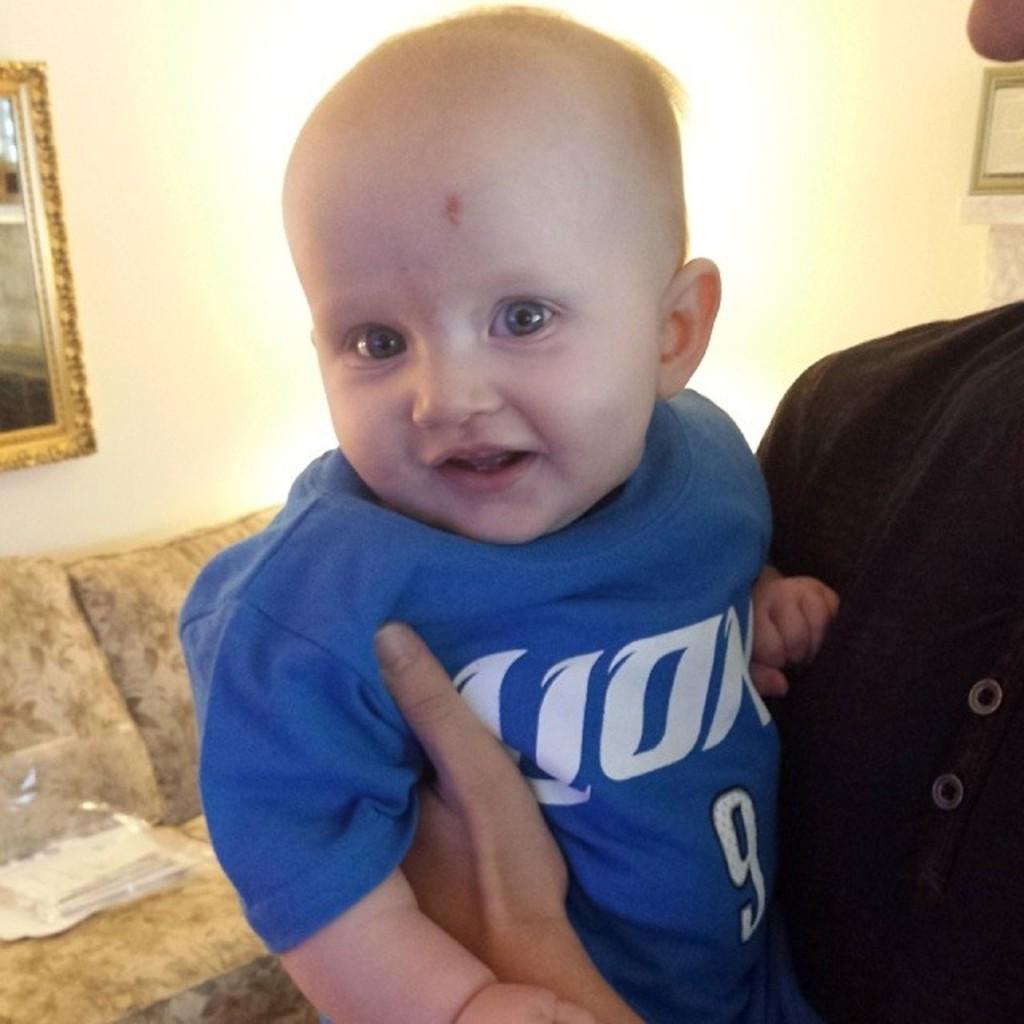What animal is on shirt?
Offer a terse response. Lion. 